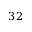Convert formula to latex. <formula><loc_0><loc_0><loc_500><loc_500>3 2</formula> 